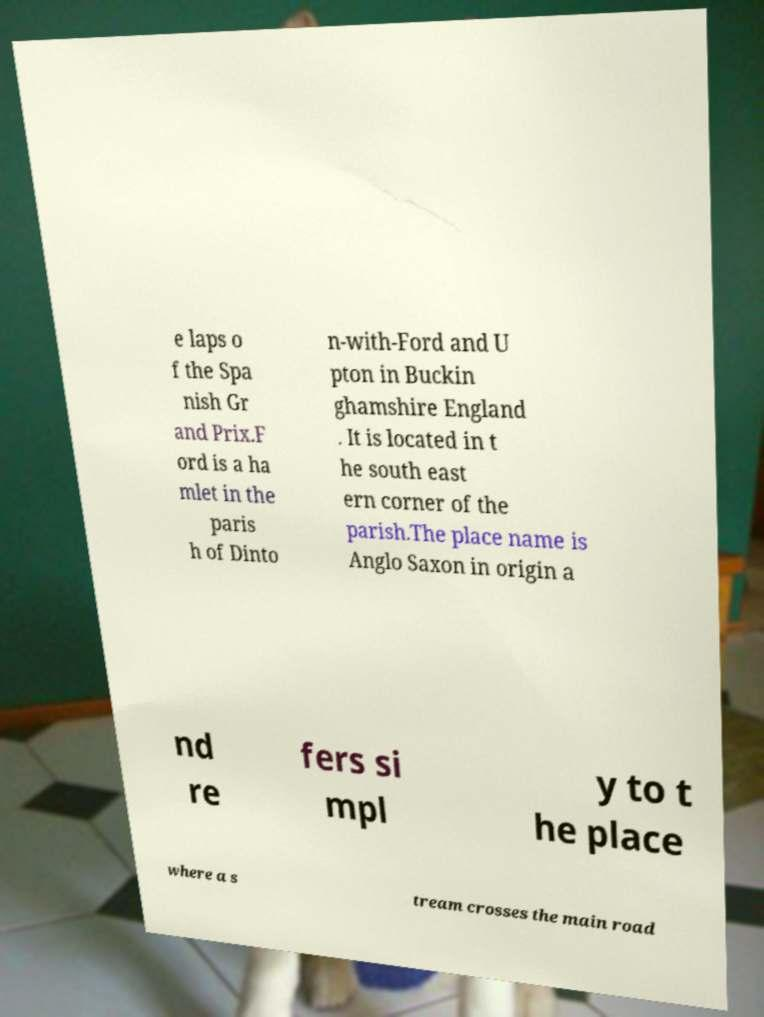Can you accurately transcribe the text from the provided image for me? e laps o f the Spa nish Gr and Prix.F ord is a ha mlet in the paris h of Dinto n-with-Ford and U pton in Buckin ghamshire England . It is located in t he south east ern corner of the parish.The place name is Anglo Saxon in origin a nd re fers si mpl y to t he place where a s tream crosses the main road 